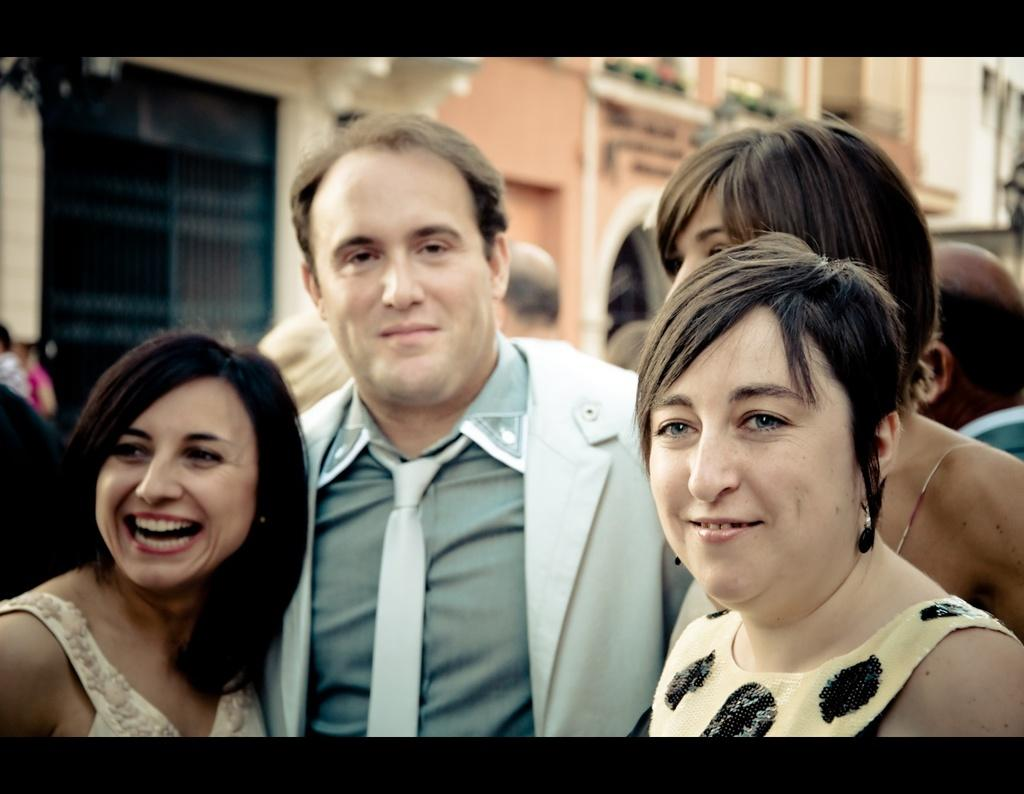How many people are in the image? There is a group of persons in the image. What are the persons wearing? The persons are wearing dresses, except for one person who is wearing a coat and tie. What can be seen in the background of the image? There is a building in the background of the image. What features does the building have? The building has windows and a door. What type of stick is being used in the battle depicted in the image? There is no battle or stick present in the image; it features a group of persons and a building in the background. How many bits are visible in the image? There are no bits present in the image. 